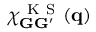Convert formula to latex. <formula><loc_0><loc_0><loc_500><loc_500>\chi _ { G G ^ { \prime } } ^ { K S } ( q )</formula> 